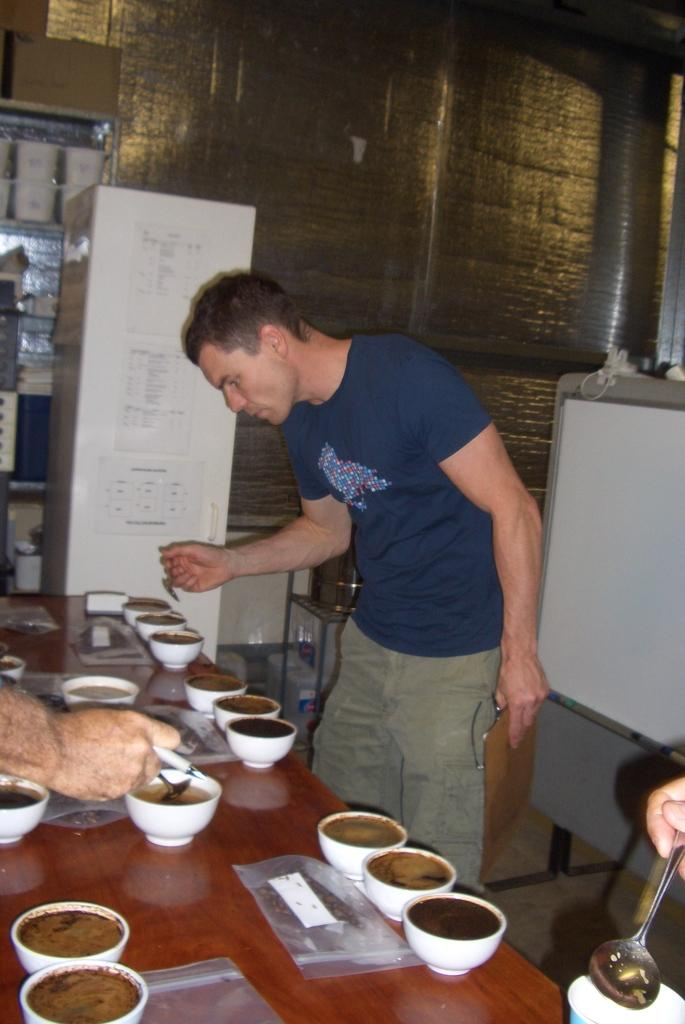What is the main subject of the image? There is a person standing in the middle of the image. What objects are present on the table in the image? There are many cups on a table. What can be seen on the right side of the image? There is a whiteboard on the right side of the image. What type of activity is the expert performing in the fog in the image? There is no expert, fog, or activity present in the image; it only features a person standing, cups on a table, and a whiteboard. 